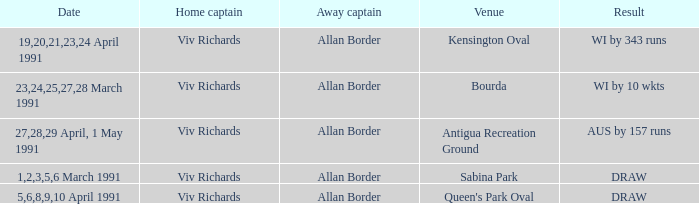Could you parse the entire table as a dict? {'header': ['Date', 'Home captain', 'Away captain', 'Venue', 'Result'], 'rows': [['19,20,21,23,24 April 1991', 'Viv Richards', 'Allan Border', 'Kensington Oval', 'WI by 343 runs'], ['23,24,25,27,28 March 1991', 'Viv Richards', 'Allan Border', 'Bourda', 'WI by 10 wkts'], ['27,28,29 April, 1 May 1991', 'Viv Richards', 'Allan Border', 'Antigua Recreation Ground', 'AUS by 157 runs'], ['1,2,3,5,6 March 1991', 'Viv Richards', 'Allan Border', 'Sabina Park', 'DRAW'], ['5,6,8,9,10 April 1991', 'Viv Richards', 'Allan Border', "Queen's Park Oval", 'DRAW']]} What dates had matches at the venue Sabina Park? 1,2,3,5,6 March 1991. 